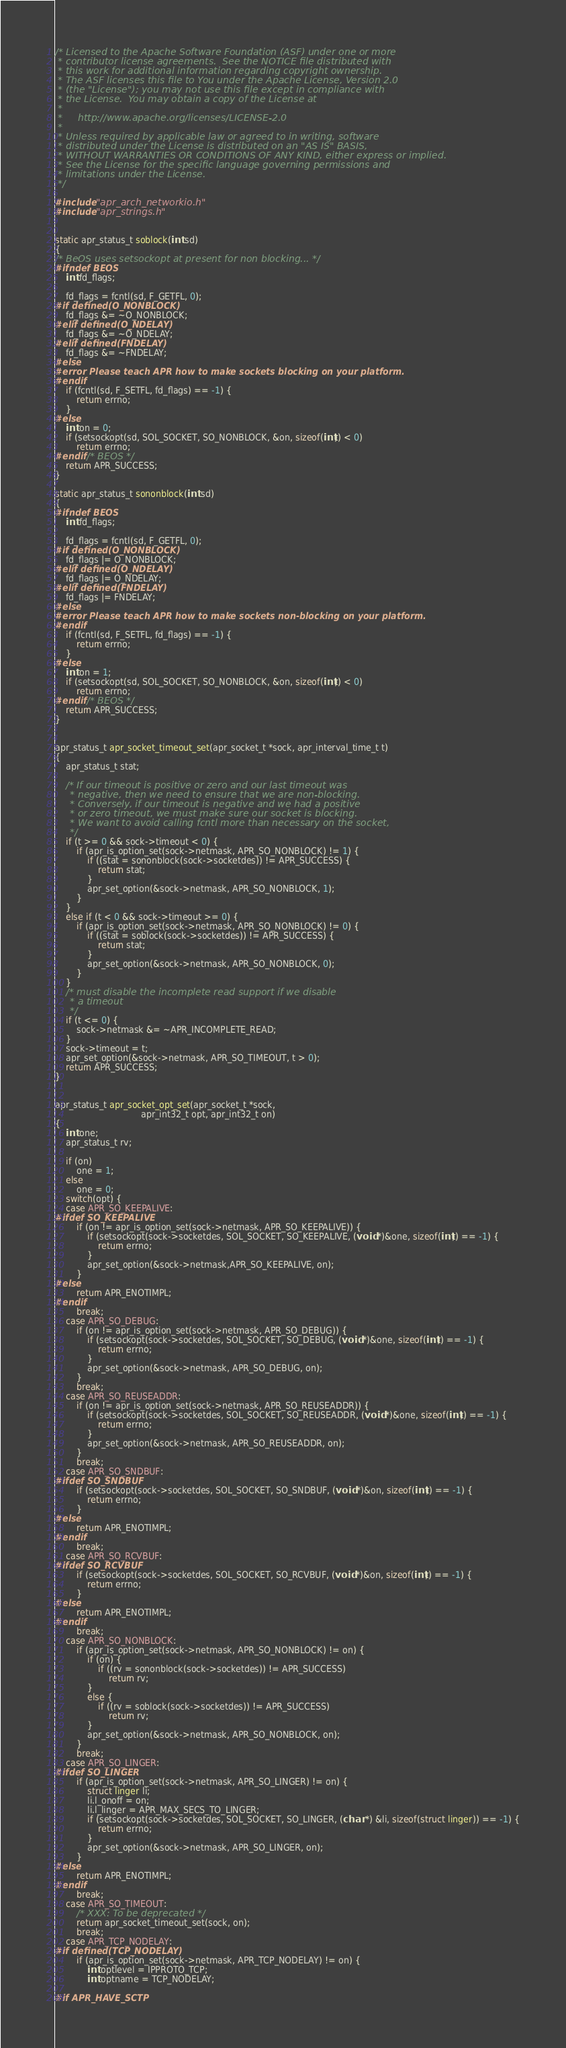<code> <loc_0><loc_0><loc_500><loc_500><_C_>/* Licensed to the Apache Software Foundation (ASF) under one or more
 * contributor license agreements.  See the NOTICE file distributed with
 * this work for additional information regarding copyright ownership.
 * The ASF licenses this file to You under the Apache License, Version 2.0
 * (the "License"); you may not use this file except in compliance with
 * the License.  You may obtain a copy of the License at
 *
 *     http://www.apache.org/licenses/LICENSE-2.0
 *
 * Unless required by applicable law or agreed to in writing, software
 * distributed under the License is distributed on an "AS IS" BASIS,
 * WITHOUT WARRANTIES OR CONDITIONS OF ANY KIND, either express or implied.
 * See the License for the specific language governing permissions and
 * limitations under the License.
 */

#include "apr_arch_networkio.h"
#include "apr_strings.h"


static apr_status_t soblock(int sd)
{
/* BeOS uses setsockopt at present for non blocking... */
#ifndef BEOS
    int fd_flags;

    fd_flags = fcntl(sd, F_GETFL, 0);
#if defined(O_NONBLOCK)
    fd_flags &= ~O_NONBLOCK;
#elif defined(O_NDELAY)
    fd_flags &= ~O_NDELAY;
#elif defined(FNDELAY)
    fd_flags &= ~FNDELAY;
#else
#error Please teach APR how to make sockets blocking on your platform.
#endif
    if (fcntl(sd, F_SETFL, fd_flags) == -1) {
        return errno;
    }
#else
    int on = 0;
    if (setsockopt(sd, SOL_SOCKET, SO_NONBLOCK, &on, sizeof(int)) < 0)
        return errno;
#endif /* BEOS */
    return APR_SUCCESS;
}

static apr_status_t sononblock(int sd)
{
#ifndef BEOS
    int fd_flags;

    fd_flags = fcntl(sd, F_GETFL, 0);
#if defined(O_NONBLOCK)
    fd_flags |= O_NONBLOCK;
#elif defined(O_NDELAY)
    fd_flags |= O_NDELAY;
#elif defined(FNDELAY)
    fd_flags |= FNDELAY;
#else
#error Please teach APR how to make sockets non-blocking on your platform.
#endif
    if (fcntl(sd, F_SETFL, fd_flags) == -1) {
        return errno;
    }
#else
    int on = 1;
    if (setsockopt(sd, SOL_SOCKET, SO_NONBLOCK, &on, sizeof(int)) < 0)
        return errno;
#endif /* BEOS */
    return APR_SUCCESS;
}


apr_status_t apr_socket_timeout_set(apr_socket_t *sock, apr_interval_time_t t)
{
    apr_status_t stat;

    /* If our timeout is positive or zero and our last timeout was
     * negative, then we need to ensure that we are non-blocking.
     * Conversely, if our timeout is negative and we had a positive
     * or zero timeout, we must make sure our socket is blocking.
     * We want to avoid calling fcntl more than necessary on the socket,
     */
    if (t >= 0 && sock->timeout < 0) {
        if (apr_is_option_set(sock->netmask, APR_SO_NONBLOCK) != 1) {
            if ((stat = sononblock(sock->socketdes)) != APR_SUCCESS) {
                return stat;
            }
            apr_set_option(&sock->netmask, APR_SO_NONBLOCK, 1);
        }
    } 
    else if (t < 0 && sock->timeout >= 0) {
        if (apr_is_option_set(sock->netmask, APR_SO_NONBLOCK) != 0) { 
            if ((stat = soblock(sock->socketdes)) != APR_SUCCESS) { 
                return stat; 
            }
            apr_set_option(&sock->netmask, APR_SO_NONBLOCK, 0);
        } 
    }
    /* must disable the incomplete read support if we disable
     * a timeout
     */
    if (t <= 0) {
        sock->netmask &= ~APR_INCOMPLETE_READ;
    }
    sock->timeout = t; 
    apr_set_option(&sock->netmask, APR_SO_TIMEOUT, t > 0);
    return APR_SUCCESS;
}


apr_status_t apr_socket_opt_set(apr_socket_t *sock, 
                                apr_int32_t opt, apr_int32_t on)
{
    int one;
    apr_status_t rv;

    if (on)
        one = 1;
    else
        one = 0;
    switch(opt) {
    case APR_SO_KEEPALIVE:
#ifdef SO_KEEPALIVE
        if (on != apr_is_option_set(sock->netmask, APR_SO_KEEPALIVE)) {
            if (setsockopt(sock->socketdes, SOL_SOCKET, SO_KEEPALIVE, (void *)&one, sizeof(int)) == -1) {
                return errno;
            }
            apr_set_option(&sock->netmask,APR_SO_KEEPALIVE, on);
        }
#else
        return APR_ENOTIMPL;
#endif
        break;
    case APR_SO_DEBUG:
        if (on != apr_is_option_set(sock->netmask, APR_SO_DEBUG)) {
            if (setsockopt(sock->socketdes, SOL_SOCKET, SO_DEBUG, (void *)&one, sizeof(int)) == -1) {
                return errno;
            }
            apr_set_option(&sock->netmask, APR_SO_DEBUG, on);
        }
        break;
    case APR_SO_REUSEADDR:
        if (on != apr_is_option_set(sock->netmask, APR_SO_REUSEADDR)) {
            if (setsockopt(sock->socketdes, SOL_SOCKET, SO_REUSEADDR, (void *)&one, sizeof(int)) == -1) {
                return errno;
            }
            apr_set_option(&sock->netmask, APR_SO_REUSEADDR, on);
        }
        break;
    case APR_SO_SNDBUF:
#ifdef SO_SNDBUF
        if (setsockopt(sock->socketdes, SOL_SOCKET, SO_SNDBUF, (void *)&on, sizeof(int)) == -1) {
            return errno;
        }
#else
        return APR_ENOTIMPL;
#endif
        break;
    case APR_SO_RCVBUF:
#ifdef SO_RCVBUF
        if (setsockopt(sock->socketdes, SOL_SOCKET, SO_RCVBUF, (void *)&on, sizeof(int)) == -1) {
            return errno;
        }
#else
        return APR_ENOTIMPL;
#endif
        break;
    case APR_SO_NONBLOCK:
        if (apr_is_option_set(sock->netmask, APR_SO_NONBLOCK) != on) {
            if (on) {
                if ((rv = sononblock(sock->socketdes)) != APR_SUCCESS) 
                    return rv;
            }
            else {
                if ((rv = soblock(sock->socketdes)) != APR_SUCCESS)
                    return rv;
            }
            apr_set_option(&sock->netmask, APR_SO_NONBLOCK, on);
        }
        break;
    case APR_SO_LINGER:
#ifdef SO_LINGER
        if (apr_is_option_set(sock->netmask, APR_SO_LINGER) != on) {
            struct linger li;
            li.l_onoff = on;
            li.l_linger = APR_MAX_SECS_TO_LINGER;
            if (setsockopt(sock->socketdes, SOL_SOCKET, SO_LINGER, (char *) &li, sizeof(struct linger)) == -1) {
                return errno;
            }
            apr_set_option(&sock->netmask, APR_SO_LINGER, on);
        }
#else
        return APR_ENOTIMPL;
#endif
        break;
    case APR_SO_TIMEOUT:
        /* XXX: To be deprecated */
        return apr_socket_timeout_set(sock, on);
        break;
    case APR_TCP_NODELAY:
#if defined(TCP_NODELAY)
        if (apr_is_option_set(sock->netmask, APR_TCP_NODELAY) != on) {
            int optlevel = IPPROTO_TCP;
            int optname = TCP_NODELAY;

#if APR_HAVE_SCTP</code> 